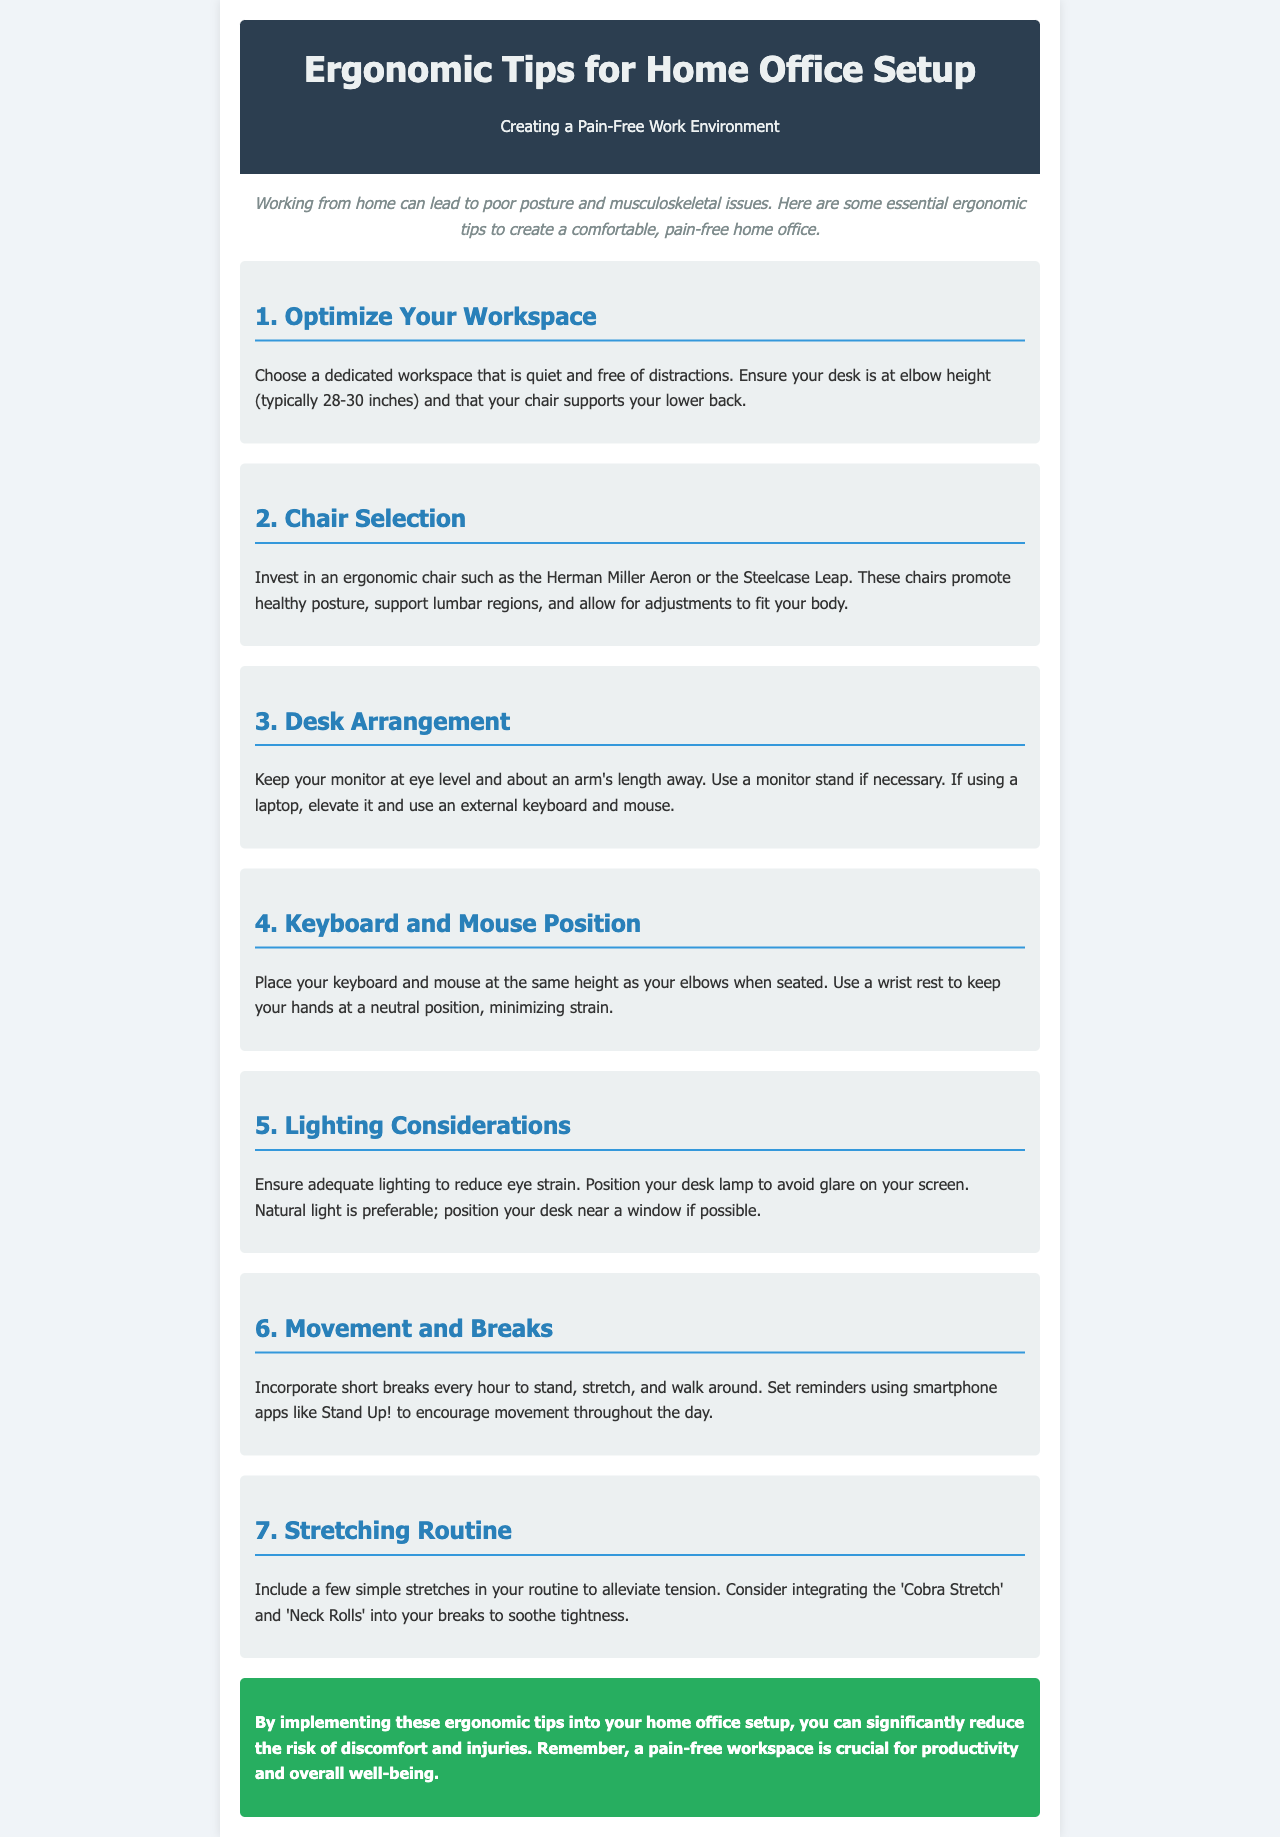What should be at elbow height? The document mentions that your desk should be at elbow height (typically 28-30 inches).
Answer: 28-30 inches What type of chair is recommended? The newsletter suggests investing in ergonomic chairs such as the Herman Miller Aeron or the Steelcase Leap.
Answer: Herman Miller Aeron, Steelcase Leap How far should the monitor be from your eyes? The text states that your monitor should be about an arm's length away.
Answer: Arm's length What advice is given for keyboard and mouse position? The document advises placing your keyboard and mouse at the same height as your elbows when seated.
Answer: Same height as your elbows What type of breaks should you incorporate? The newsletter recommends incorporating short breaks every hour to stand, stretch, and walk around.
Answer: Short breaks every hour What are two stretches mentioned in the document? The document suggests including the 'Cobra Stretch' and 'Neck Rolls' in your routine to alleviate tension.
Answer: Cobra Stretch, Neck Rolls What should lighting reduce? The document mentions that adequate lighting is necessary to reduce eye strain.
Answer: Eye strain What color is the header background? The header background color in the document is described as dark blue.
Answer: Dark blue 